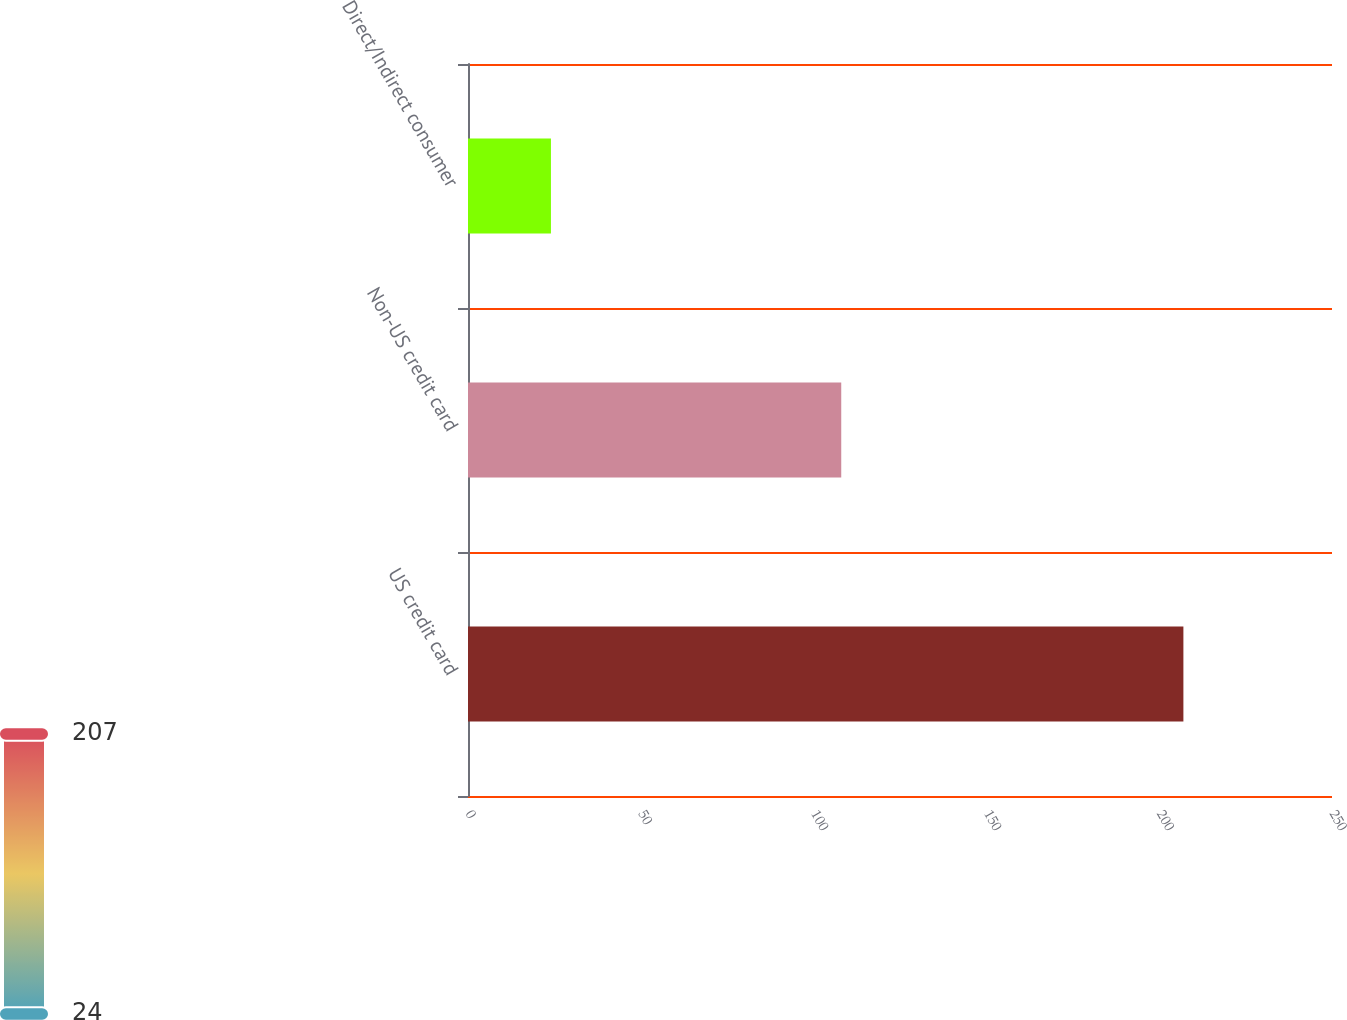Convert chart. <chart><loc_0><loc_0><loc_500><loc_500><bar_chart><fcel>US credit card<fcel>Non-US credit card<fcel>Direct/Indirect consumer<nl><fcel>207<fcel>108<fcel>24<nl></chart> 